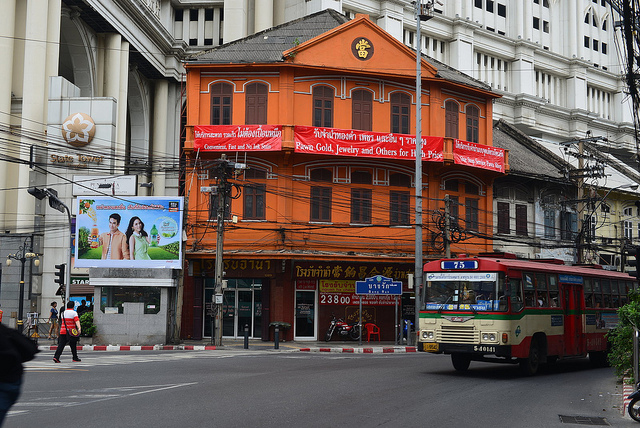<image>What is the word on the nearest building to the right? It is ambiguous what the word on the nearest building to the right is. It is possibly "mcdonald's", "jewelry", "pawn", or "238", but it cannot be clearly determined from the image. What is the name of the city this bus is touring? It is uncertain what city the bus is touring. The city can be Paris, San Francisco, London, New York, Hong Kong, Shanghai, or even Indonesia. How many stories is the orange building? I am not sure how many stories the orange building has. It might have 2 or 3 stories. What is the name of the city this bus is touring? I don't know the name of the city this bus is touring. It is unknown. What is the word on the nearest building to the right? I don't know what word is on the nearest building to the right. There are several possibilities such as "mcdonald's", 'jewelry', "can't see it", 'not in english', 'no', 'pawn', '238'. How many stories is the orange building? I don't know how many stories the orange building has. It can be 2 or 3. 